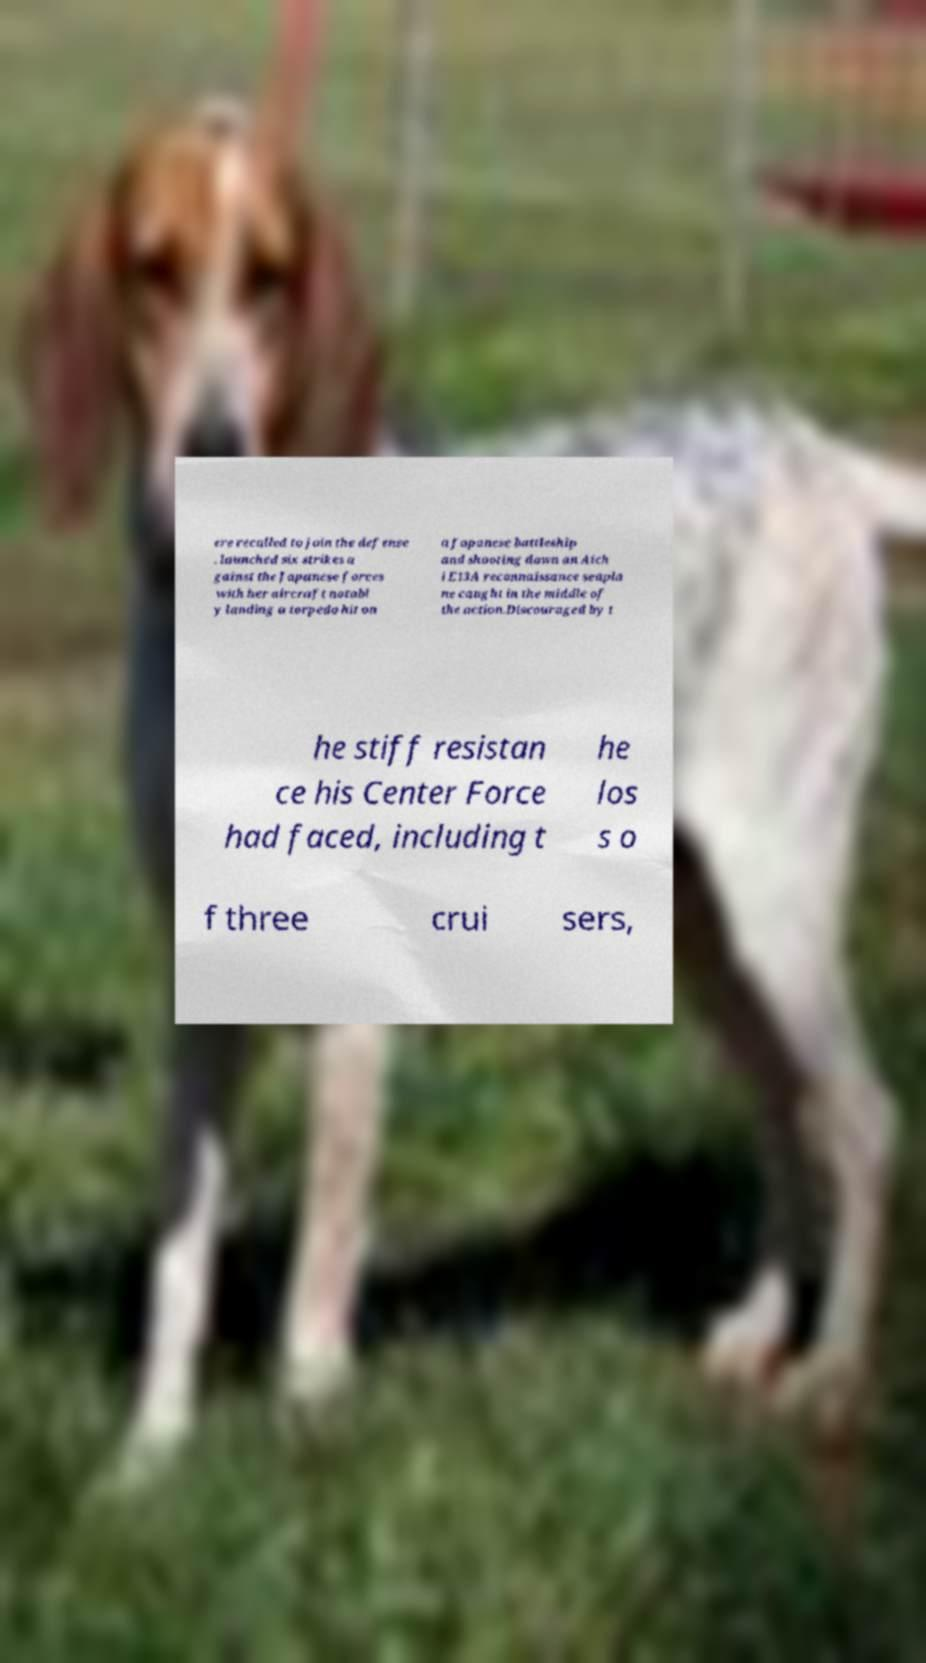Please read and relay the text visible in this image. What does it say? ere recalled to join the defense . launched six strikes a gainst the Japanese forces with her aircraft notabl y landing a torpedo hit on a Japanese battleship and shooting down an Aich i E13A reconnaissance seapla ne caught in the middle of the action.Discouraged by t he stiff resistan ce his Center Force had faced, including t he los s o f three crui sers, 